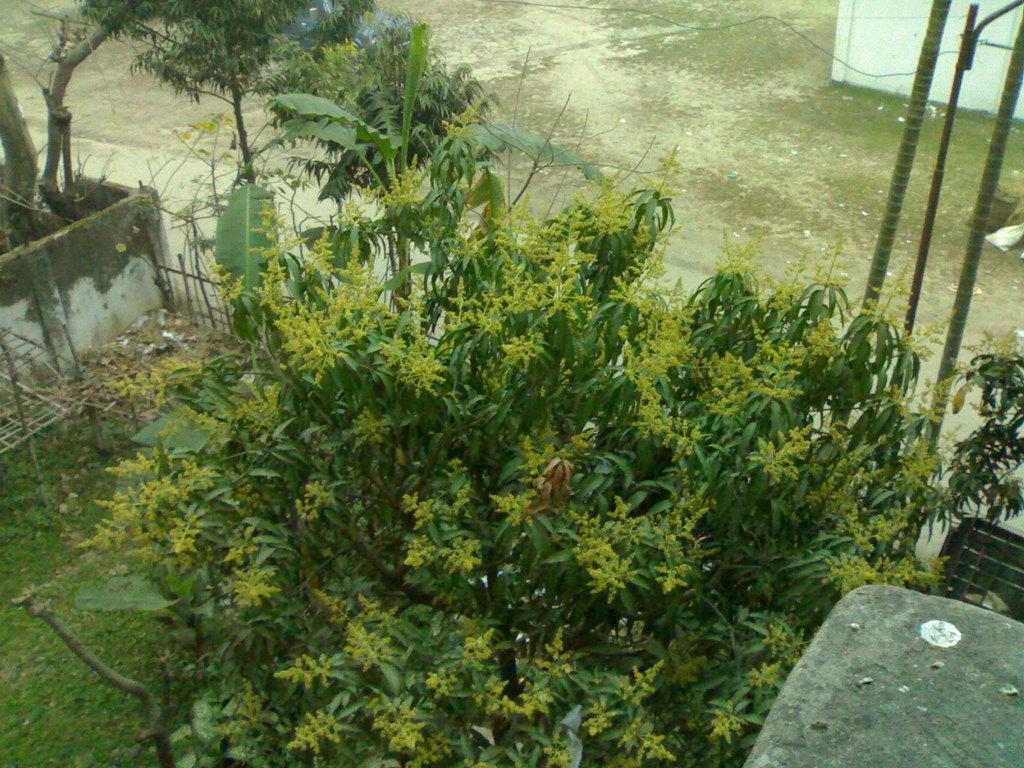In one or two sentences, can you explain what this image depicts? At the bottom of the picture, we see trees and grass. Beside that, we see wooden sticks and a wooden fence. On the left side, we see a wall and a tree. On the right side, we see a wall and a gate. In the right top, we see the wall in white color and we even see the poles. 